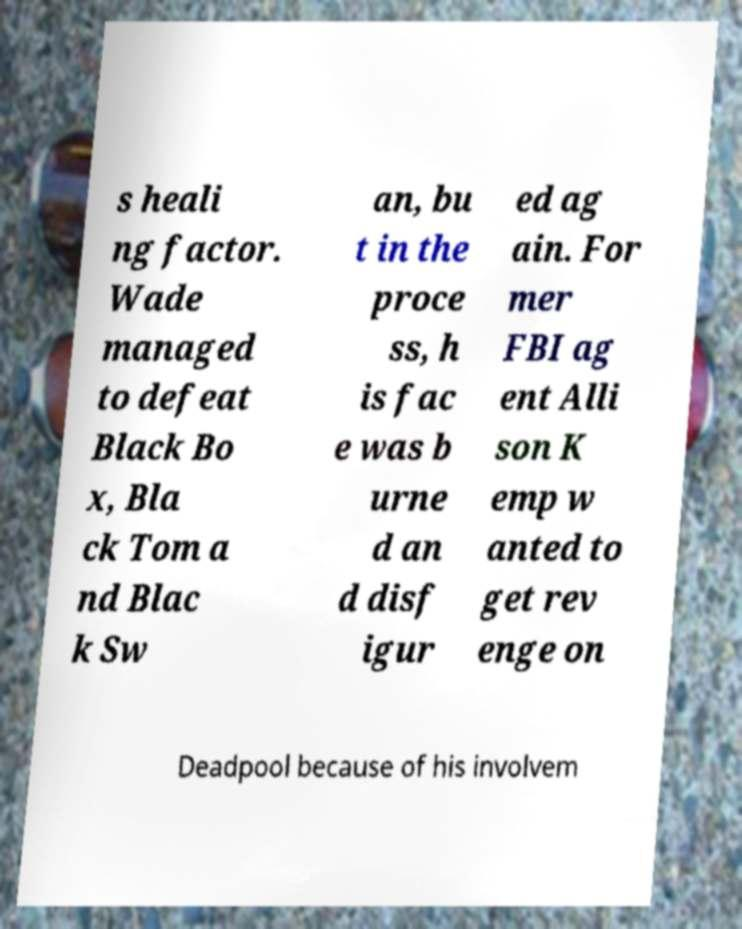Could you extract and type out the text from this image? s heali ng factor. Wade managed to defeat Black Bo x, Bla ck Tom a nd Blac k Sw an, bu t in the proce ss, h is fac e was b urne d an d disf igur ed ag ain. For mer FBI ag ent Alli son K emp w anted to get rev enge on Deadpool because of his involvem 